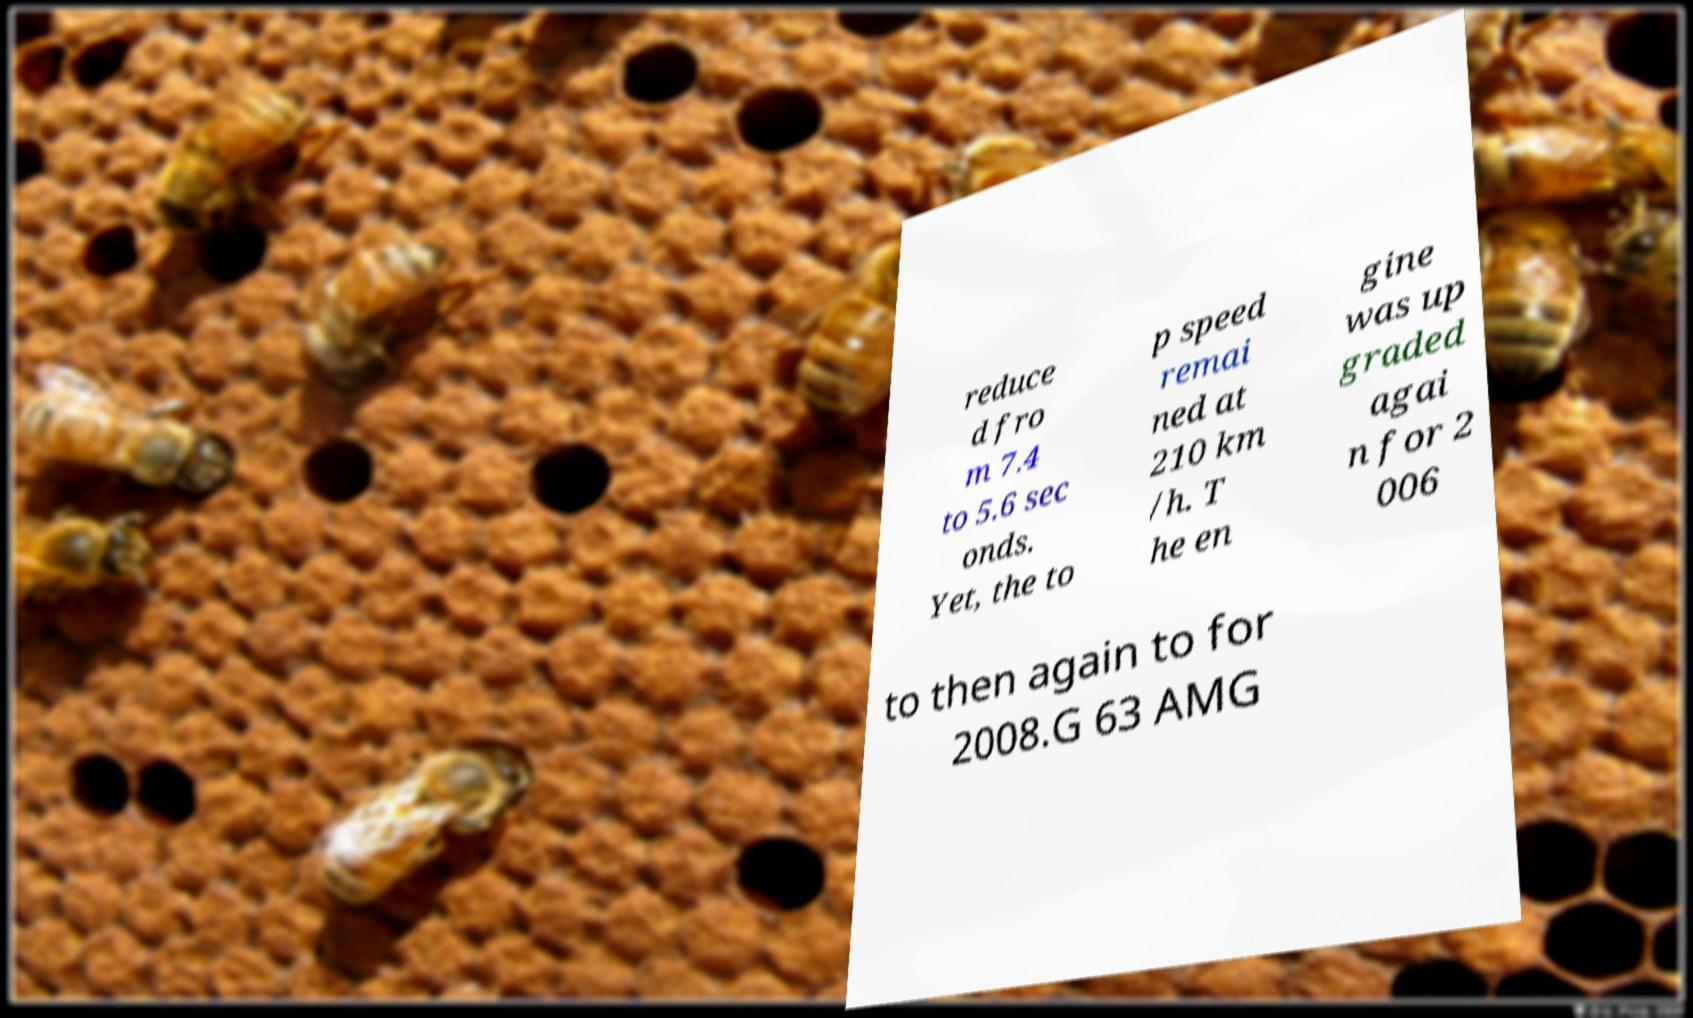Can you read and provide the text displayed in the image?This photo seems to have some interesting text. Can you extract and type it out for me? reduce d fro m 7.4 to 5.6 sec onds. Yet, the to p speed remai ned at 210 km /h. T he en gine was up graded agai n for 2 006 to then again to for 2008.G 63 AMG 